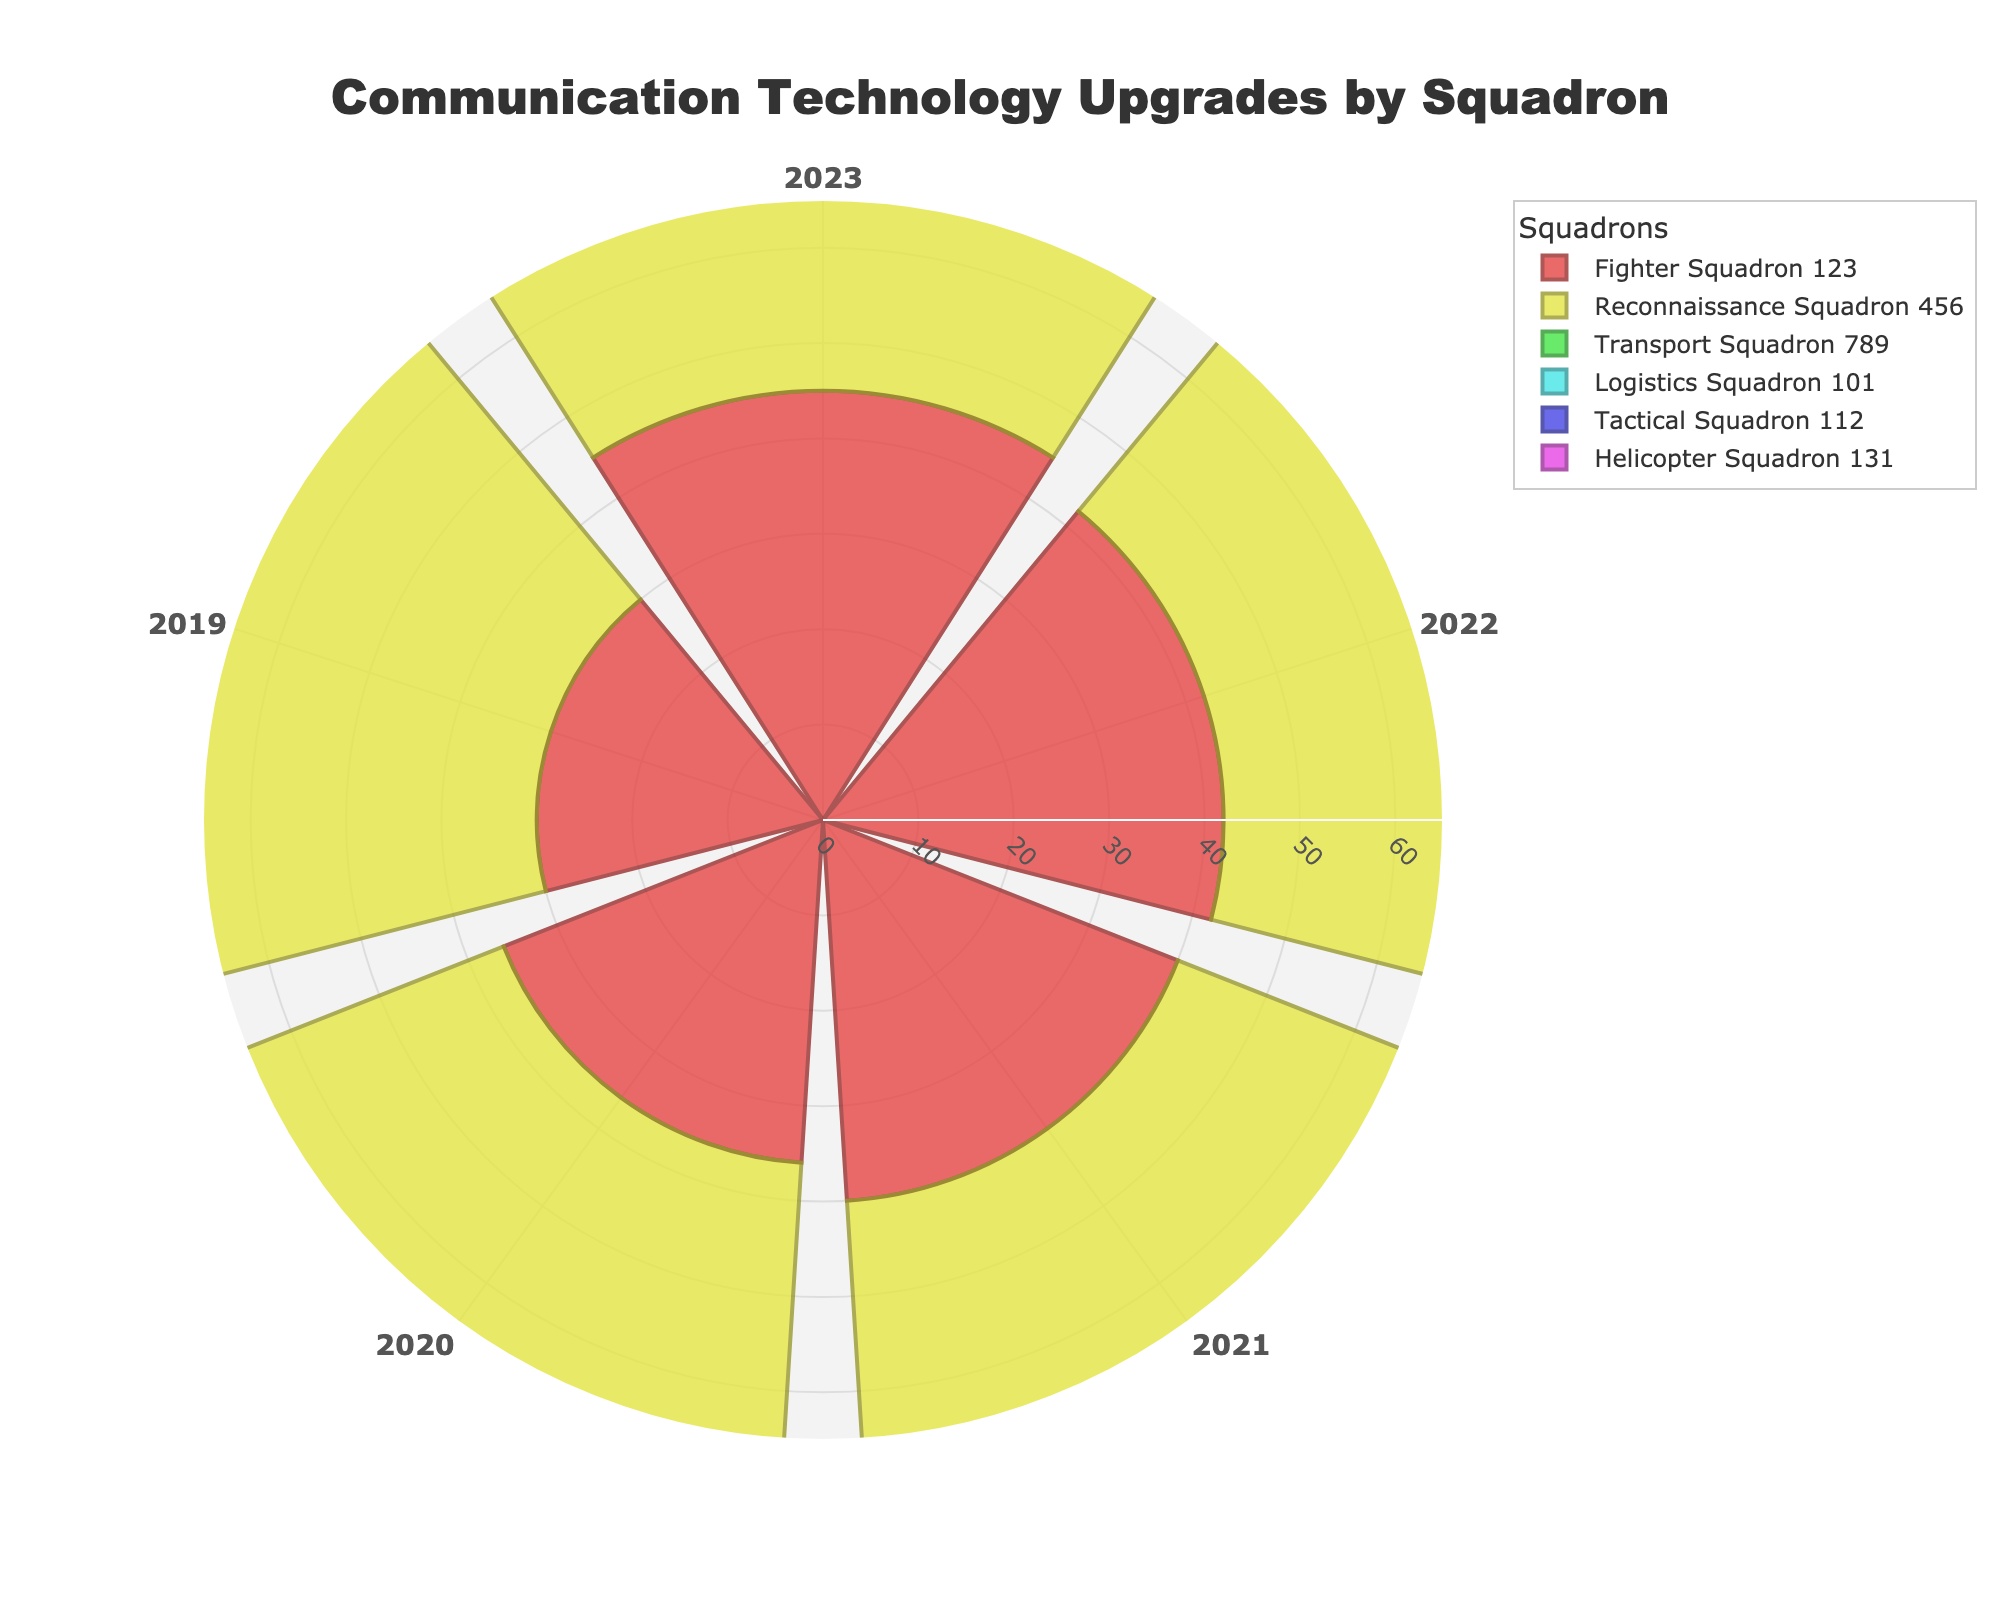what is the title of the figure? The title of the figure is found at the top of the chart. It provides an overall description of the data being visualized, which in this case indicates the subject matter and the type of measure.
Answer: Communication Technology Upgrades by Squadron how many years of data are represented in the figure? By looking at the angular axis (categories) of the polar area chart, each sector represents a different year. Counting these sectors will give the total number of years represented.
Answer: 5 which squadron had the most upgrades in 2023? To find this, determine which bar extending from the center outward is longest among the 2023 data points for each squadron. This corresponds to the highest value.
Answer: Tactical Squadron 112 which squadron had the second-highest total upgrades over the entire period? Sum up the upgrades over all years for each squadron and compare the sums. Identify the squadron with the second-highest total.
Answer: Logistics Squadron 101 what is the average number of upgrades for Fighter Squadron 123 over the entire period? Add up the number of upgrades for Fighter Squadron 123 across all years and divide by the number of years (5). ((45+42+40+36+30)/5 = 38.6)
Answer: 38.6 which year had the highest total upgrades across all squadrons? Sum the upgrades for all squadrons for each year and compare the totals. Identify the year with the highest total.
Answer: 2023 what is the difference in upgrades between the Tactical Squadron 112 and Reconnaissance Squadron 456 in 2021? Subtract the number of upgrades for Reconnaissance Squadron 456 in 2021 from the number of upgrades for Tactical Squadron 112 in the same year. (54 - 44 = 10)
Answer: 10 by how much did the upgrades for Helicopter Squadron 131 increase from 2019 to 2023? Subtract the number of upgrades in 2019 from the number of upgrades in 2023 for Helicopter Squadron 131. (43 - 32 = 11)
Answer: 11 what is the trend of upgrades for the Transport Squadron 789 over the years? Observe the pattern of the data points for Transport Squadron 789 from 2019 to 2023. Summarize whether it is generally increasing, decreasing, or remaining stable.
Answer: Increasing 